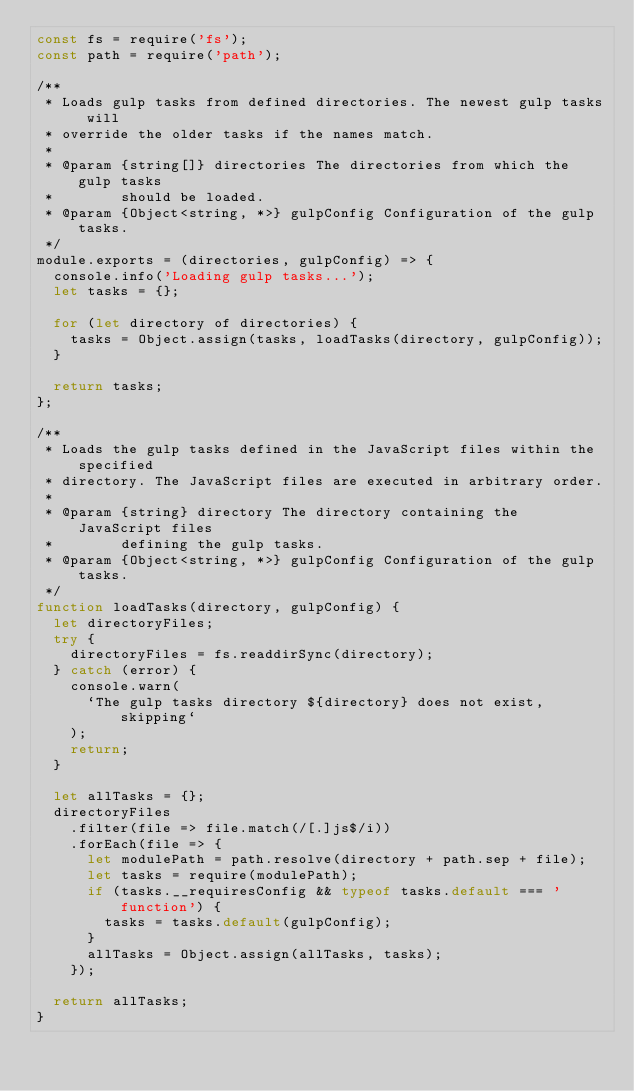<code> <loc_0><loc_0><loc_500><loc_500><_JavaScript_>const fs = require('fs');
const path = require('path');

/**
 * Loads gulp tasks from defined directories. The newest gulp tasks will
 * override the older tasks if the names match.
 *
 * @param {string[]} directories The directories from which the gulp tasks
 *        should be loaded.
 * @param {Object<string, *>} gulpConfig Configuration of the gulp tasks.
 */
module.exports = (directories, gulpConfig) => {
  console.info('Loading gulp tasks...');
  let tasks = {};

  for (let directory of directories) {
    tasks = Object.assign(tasks, loadTasks(directory, gulpConfig));
  }

  return tasks;
};

/**
 * Loads the gulp tasks defined in the JavaScript files within the specified
 * directory. The JavaScript files are executed in arbitrary order.
 *
 * @param {string} directory The directory containing the JavaScript files
 *        defining the gulp tasks.
 * @param {Object<string, *>} gulpConfig Configuration of the gulp tasks.
 */
function loadTasks(directory, gulpConfig) {
  let directoryFiles;
  try {
    directoryFiles = fs.readdirSync(directory);
  } catch (error) {
    console.warn(
      `The gulp tasks directory ${directory} does not exist, skipping`
    );
    return;
  }

  let allTasks = {};
  directoryFiles
    .filter(file => file.match(/[.]js$/i))
    .forEach(file => {
      let modulePath = path.resolve(directory + path.sep + file);
      let tasks = require(modulePath);
      if (tasks.__requiresConfig && typeof tasks.default === 'function') {
        tasks = tasks.default(gulpConfig);
      }
      allTasks = Object.assign(allTasks, tasks);
    });

  return allTasks;
}
</code> 